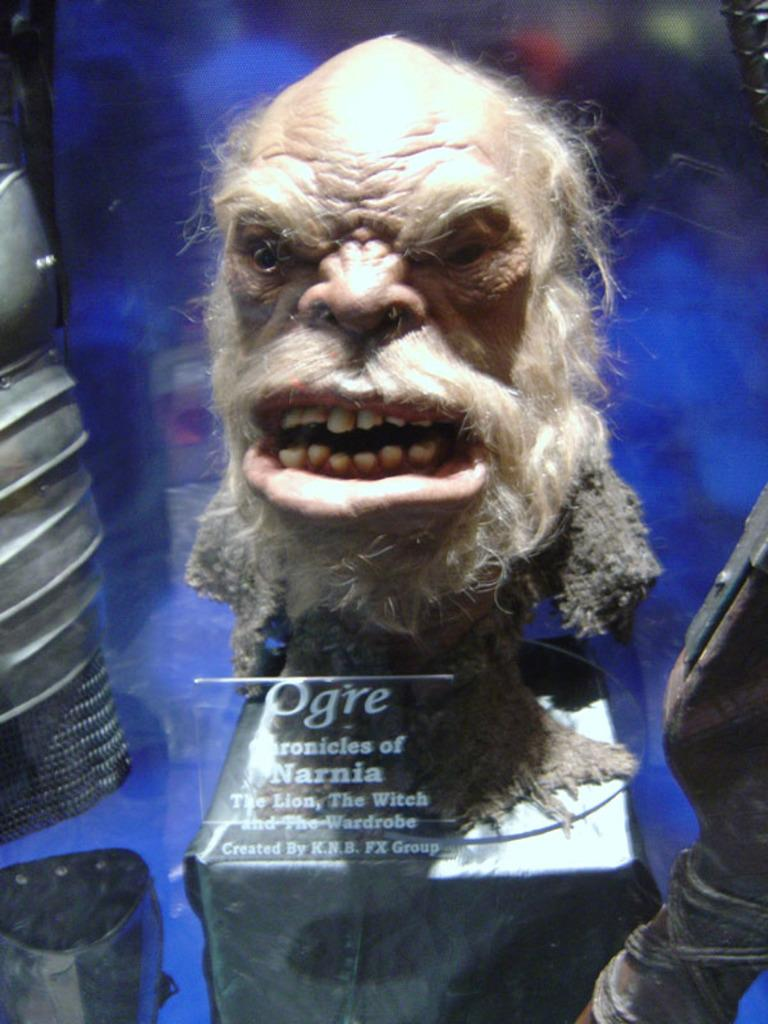What type of character's head is in the image? There is the head of a Narnia ogre in the image. What object is in the front of the image? There is a glass in the front of the image. Is there any text on the glass? Yes, there is text on the glass. What type of comfort can be seen in the image? There is no reference to comfort in the image, as it features the head of a Narnia ogre and a glass with text. 